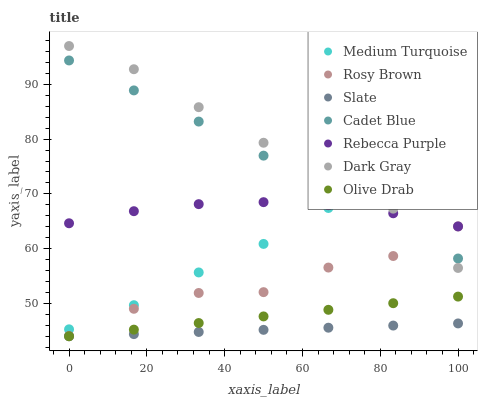Does Slate have the minimum area under the curve?
Answer yes or no. Yes. Does Dark Gray have the maximum area under the curve?
Answer yes or no. Yes. Does Rosy Brown have the minimum area under the curve?
Answer yes or no. No. Does Rosy Brown have the maximum area under the curve?
Answer yes or no. No. Is Slate the smoothest?
Answer yes or no. Yes. Is Rosy Brown the roughest?
Answer yes or no. Yes. Is Rosy Brown the smoothest?
Answer yes or no. No. Is Slate the roughest?
Answer yes or no. No. Does Slate have the lowest value?
Answer yes or no. Yes. Does Rosy Brown have the lowest value?
Answer yes or no. No. Does Dark Gray have the highest value?
Answer yes or no. Yes. Does Rosy Brown have the highest value?
Answer yes or no. No. Is Slate less than Rosy Brown?
Answer yes or no. Yes. Is Rosy Brown greater than Olive Drab?
Answer yes or no. Yes. Does Rebecca Purple intersect Medium Turquoise?
Answer yes or no. Yes. Is Rebecca Purple less than Medium Turquoise?
Answer yes or no. No. Is Rebecca Purple greater than Medium Turquoise?
Answer yes or no. No. Does Slate intersect Rosy Brown?
Answer yes or no. No. 